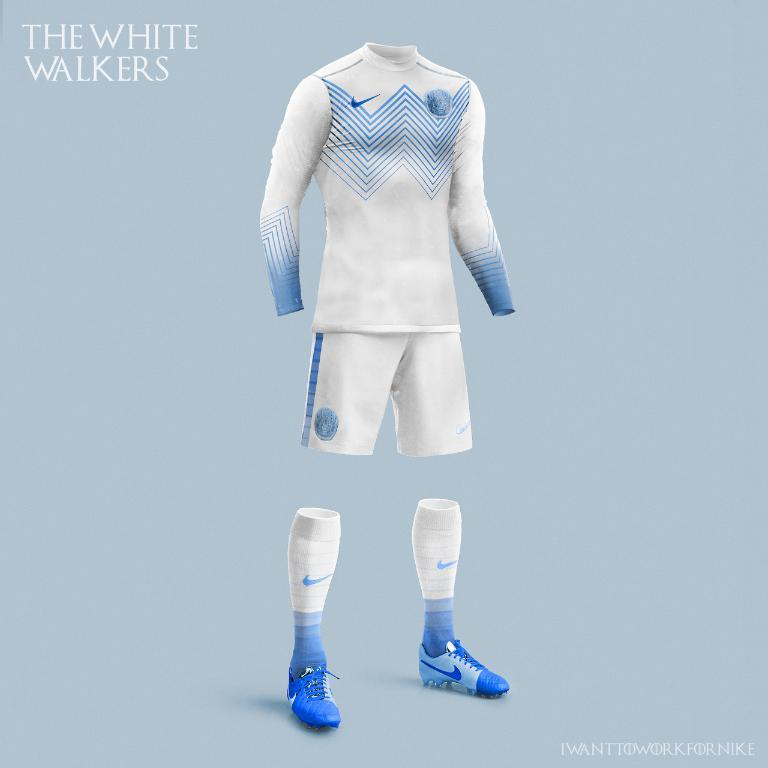What type of clothing items can be seen in the image? There are clothes in the image. Can you identify any specific type of clothing item among the clothes? Yes, there are socks in the image. What other footwear-related items can be seen in the image? There are shoes in the image. What type of reaction can be seen in the image? There is no reaction visible in the image; it only shows clothes, socks, and shoes. Can you describe the wing of the bird in the image? There is no bird or wing present in the image. 